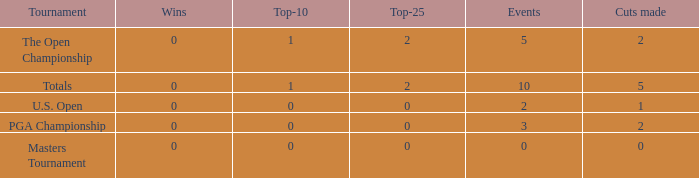What is the total number of top-25s for events with 0 wins? 0.0. 